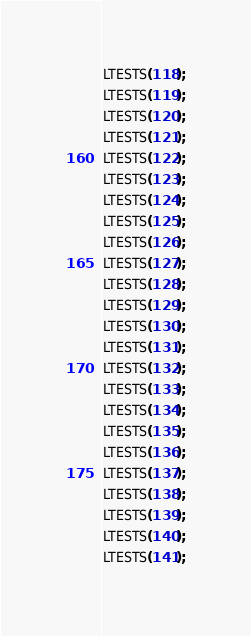Convert code to text. <code><loc_0><loc_0><loc_500><loc_500><_Cuda_>LTESTS(118);
LTESTS(119);
LTESTS(120);
LTESTS(121);
LTESTS(122);
LTESTS(123);
LTESTS(124);
LTESTS(125);
LTESTS(126);
LTESTS(127);
LTESTS(128);
LTESTS(129);
LTESTS(130);
LTESTS(131);
LTESTS(132);
LTESTS(133);
LTESTS(134);
LTESTS(135);
LTESTS(136);
LTESTS(137);
LTESTS(138);
LTESTS(139);
LTESTS(140);
LTESTS(141);


</code> 